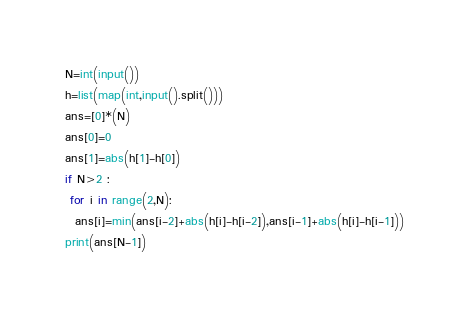Convert code to text. <code><loc_0><loc_0><loc_500><loc_500><_Python_>N=int(input())
h=list(map(int,input().split()))
ans=[0]*(N)
ans[0]=0
ans[1]=abs(h[1]-h[0])
if N>2 :
 for i in range(2,N):
  ans[i]=min(ans[i-2]+abs(h[i]-h[i-2]),ans[i-1]+abs(h[i]-h[i-1]))
print(ans[N-1])
</code> 